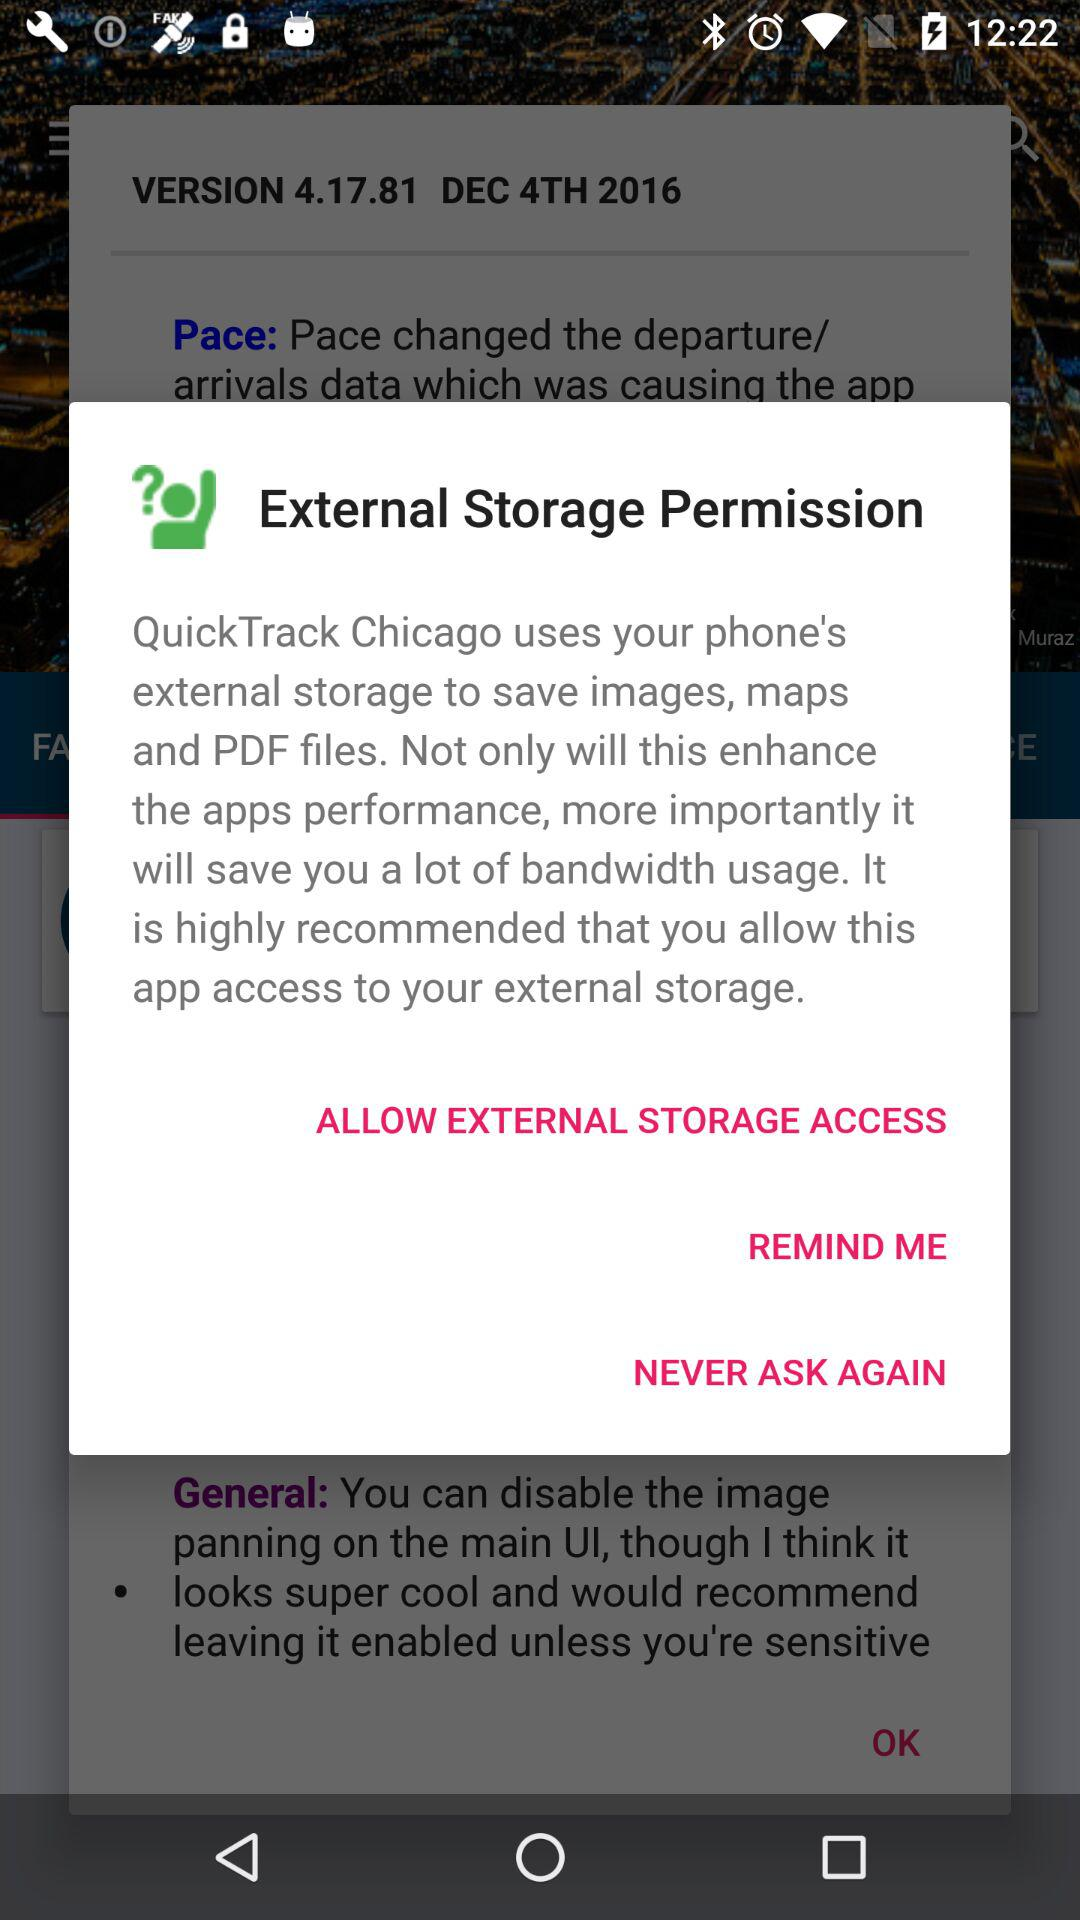What is the release date of the version? The release date is December 4th, 2016. 